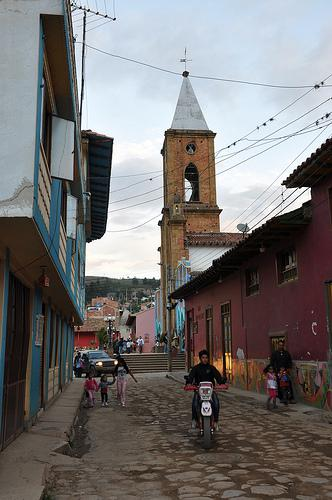Question: where are the child in the picture?
Choices:
A. On the left.
B. At the playground.
C. The side of the street.
D. On the merry-go-round.
Answer with the letter. Answer: C Question: how many children are in the photo?
Choices:
A. 2.
B. 4.
C. 3.
D. 6.
Answer with the letter. Answer: B Question: who are in the photo?
Choices:
A. All the cats in the shelter.
B. All the dogs in the animal shelter.
C. People.
D. The corporation bigwigs.
Answer with the letter. Answer: C Question: when was the picture taken of the people?
Choices:
A. At a family gathering.
B. At the corporation's summer picnic.
C. Daytime.
D. At last year's MS walkathon.
Answer with the letter. Answer: C Question: why is the woman holding the child's hand?
Choices:
A. To drag the child away from the candy aisle.
B. To keep the child safe.
C. To comfort the child.
D. They are playing game.
Answer with the letter. Answer: B Question: what is in the background of the picture?
Choices:
A. A busy street.
B. A mailbox.
C. A tower.
D. A rose garden.
Answer with the letter. Answer: C Question: what is in the photo's foreground?
Choices:
A. Buildings.
B. A tower.
C. A light pole.
D. A bridge.
Answer with the letter. Answer: A 